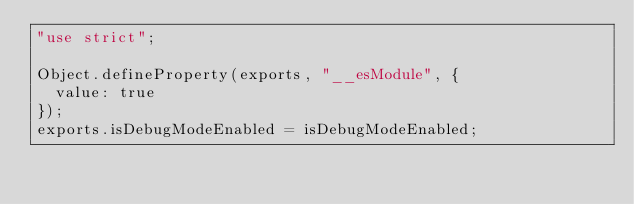<code> <loc_0><loc_0><loc_500><loc_500><_JavaScript_>"use strict";

Object.defineProperty(exports, "__esModule", {
  value: true
});
exports.isDebugModeEnabled = isDebugModeEnabled;</code> 